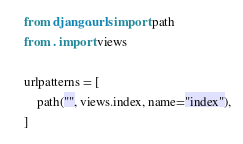<code> <loc_0><loc_0><loc_500><loc_500><_Python_>from django.urls import path
from . import views

urlpatterns = [
    path("", views.index, name="index"),
]
</code> 